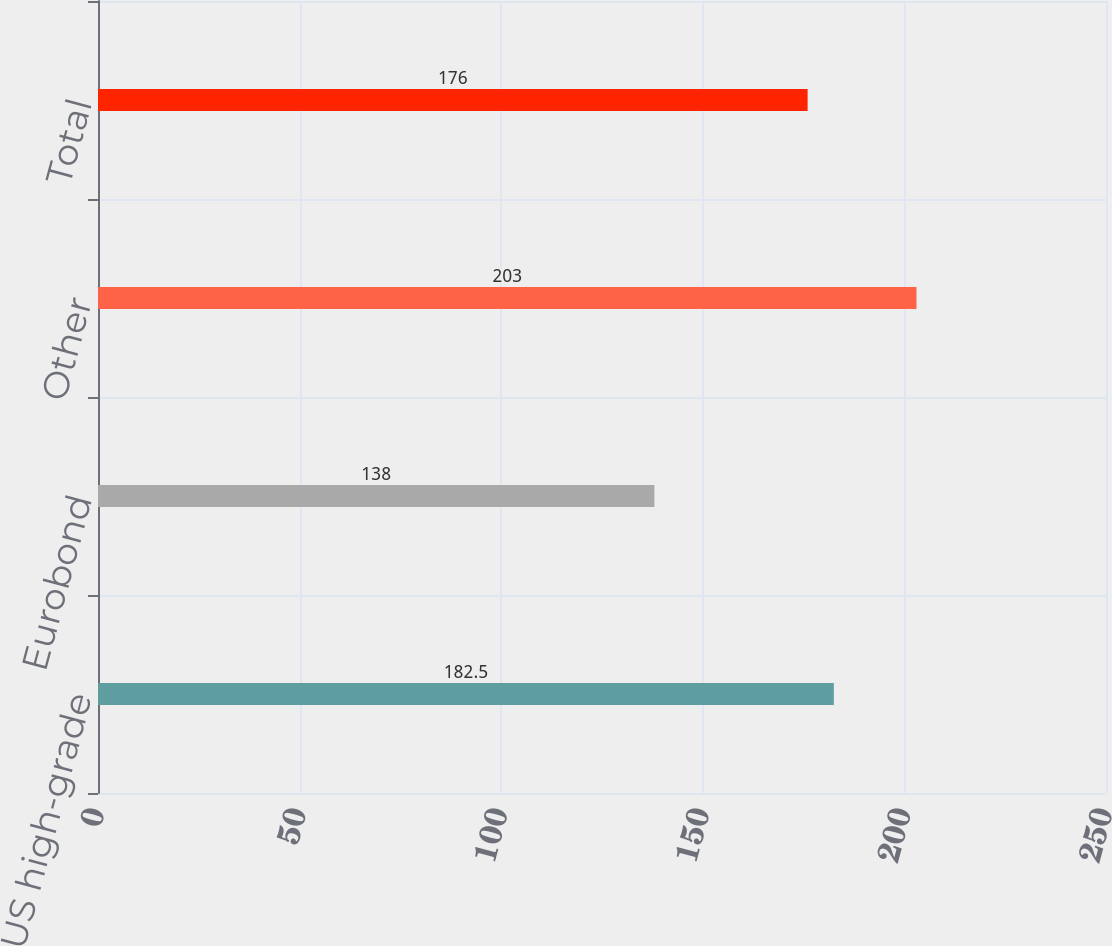Convert chart. <chart><loc_0><loc_0><loc_500><loc_500><bar_chart><fcel>US high-grade<fcel>Eurobond<fcel>Other<fcel>Total<nl><fcel>182.5<fcel>138<fcel>203<fcel>176<nl></chart> 